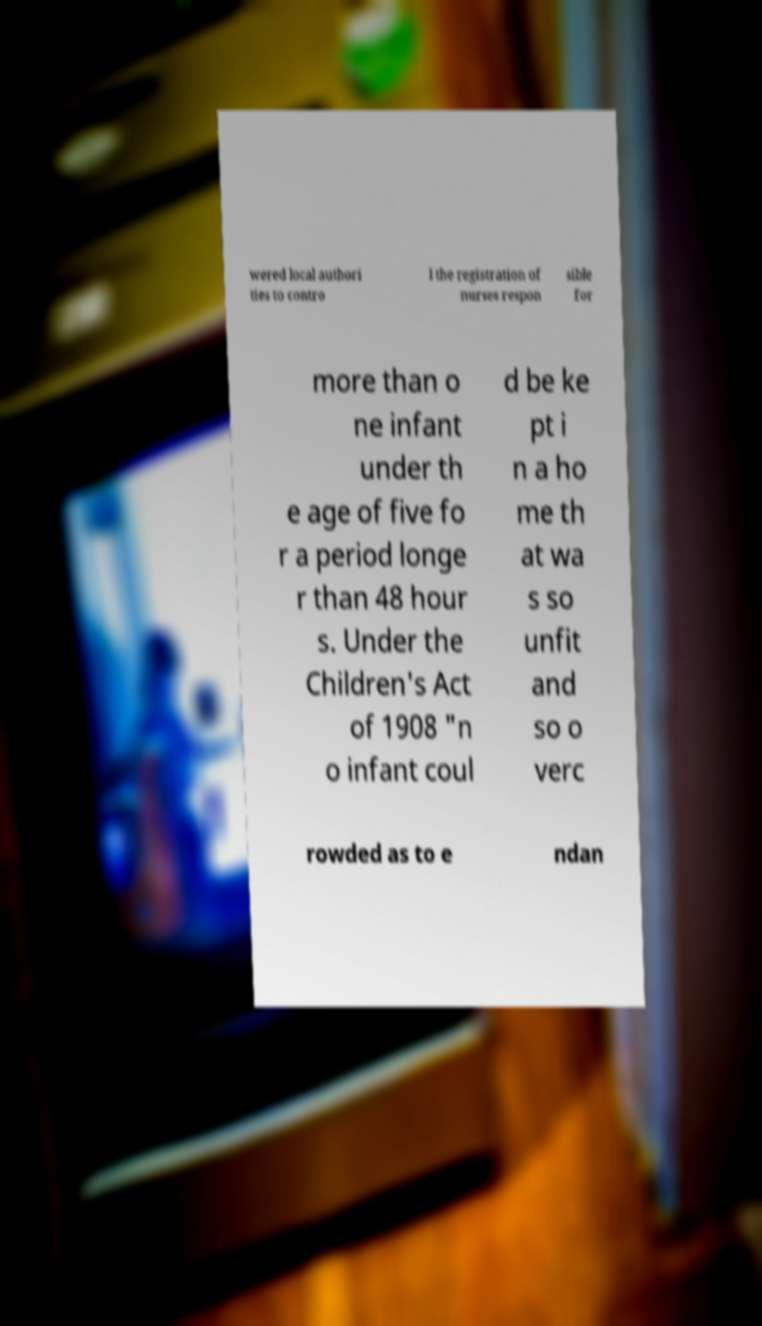Please read and relay the text visible in this image. What does it say? wered local authori ties to contro l the registration of nurses respon sible for more than o ne infant under th e age of five fo r a period longe r than 48 hour s. Under the Children's Act of 1908 "n o infant coul d be ke pt i n a ho me th at wa s so unfit and so o verc rowded as to e ndan 